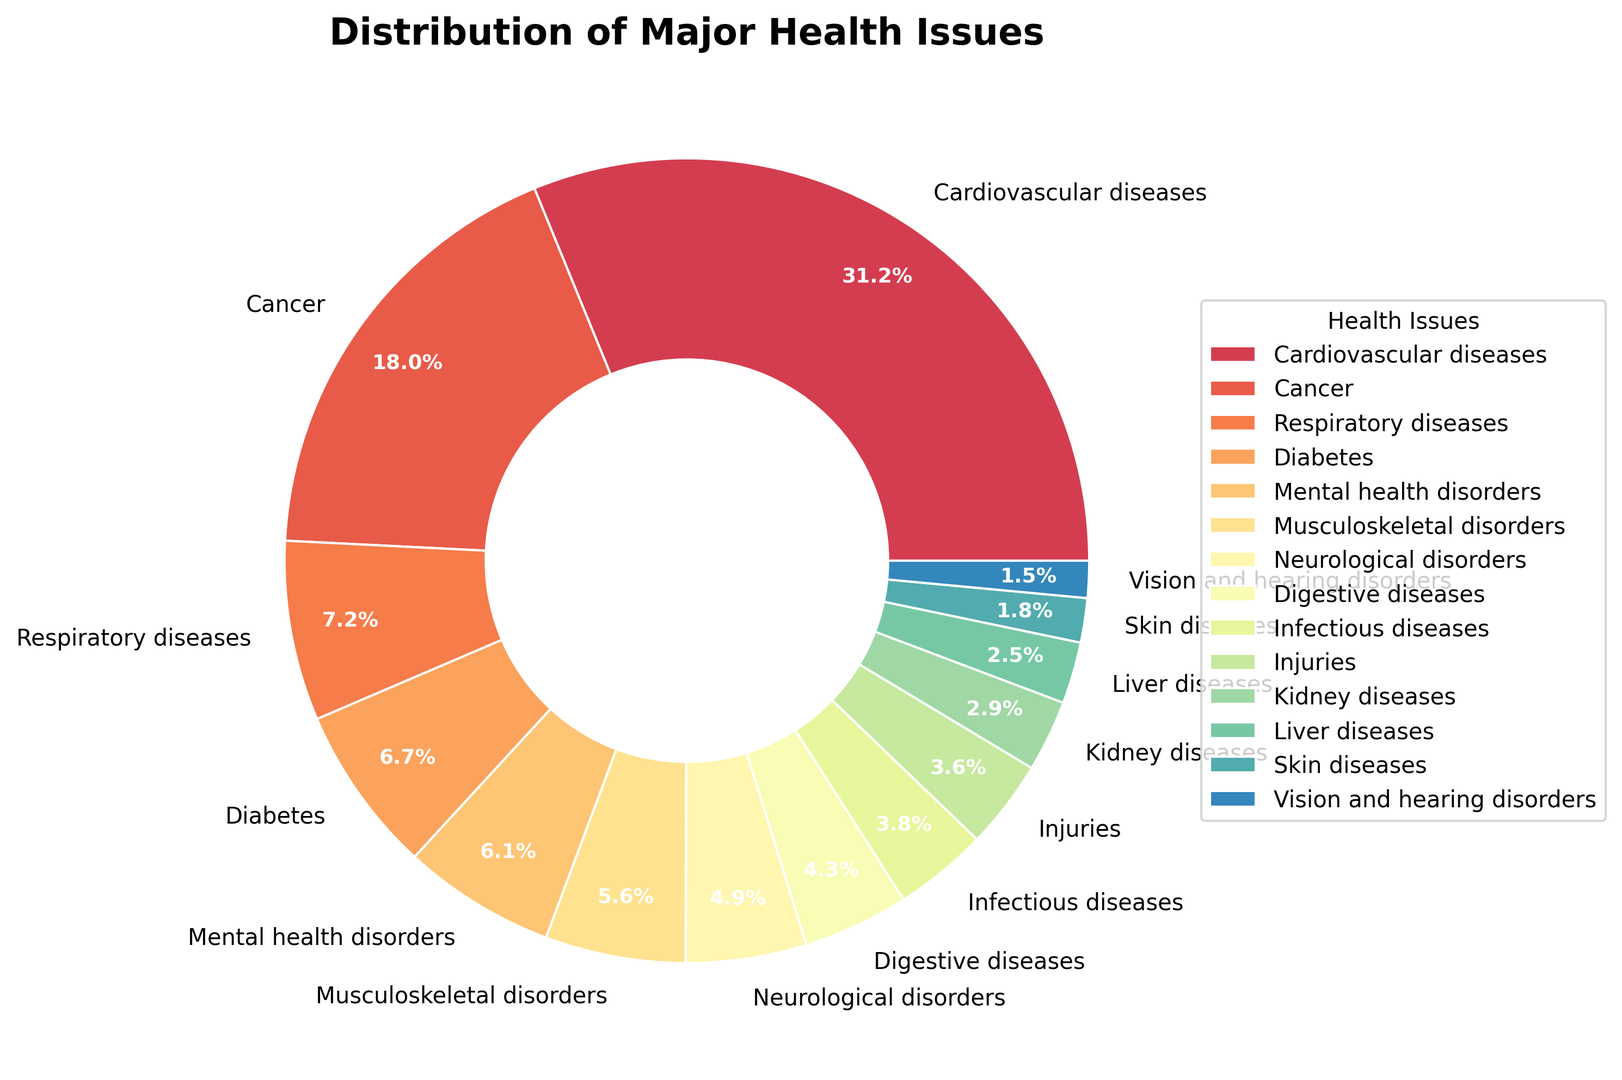Which health issue has the highest percentage? The largest section of the pie chart, representing Cardiovascular diseases, shows the highest percentage.
Answer: Cardiovascular diseases What is the combined percentage of Respiratory diseases and Diabetes? Add the percentage values for Respiratory diseases (7.3%) and Diabetes (6.8%) from the chart: 7.3 + 6.8 = 14.1%
Answer: 14.1% Which health issue has a greater percentage, Musculoskeletal disorders or Mental health disorders? Compare the percentages from the chart: Musculoskeletal disorders (5.7%) and Mental health disorders (6.2%). Mental health disorders have a greater percentage.
Answer: Mental health disorders How does the percentage of Liver diseases compare to that of Kidney diseases? Find the percentages from the chart: Liver diseases (2.5%) and Kidney diseases (2.9%). Kidney diseases have a higher percentage than Liver diseases.
Answer: Kidney diseases What is the percentage difference between Cancer and Infectious diseases? Calculate the difference between the percentages of Cancer (18.2%) and Infectious diseases (3.8%): 18.2 - 3.8 = 14.4%
Answer: 14.4% Which three health issues have the smallest percentages and what is their combined percentage? Identify the health issues with the smallest percentages: Vision and hearing disorders (1.5%), Skin diseases (1.8%), and Liver diseases (2.5%). Add them together: 1.5 + 1.8 + 2.5 = 5.8%
Answer: 5.8% What is the average percentage of the top four health issues? Identify the top four health issues: Cardiovascular diseases (31.5%), Cancer (18.2%), Respiratory diseases (7.3%), and Diabetes (6.8%). Calculate the average: (31.5 + 18.2 + 7.3 + 6.8) / 4 = 15.95%
Answer: 15.95% Which is the least prevalent health issue and what color represents it on the chart? The least prevalent health issue is Vision and hearing disorders (1.5%). It is represented by the section color corresponding to its placement in the legend.
Answer: Vision and hearing disorders, observe the color in the legend What is the total percentage of health issues that account for less than 5% each? Identify the health issues with percentages less than 5%: Neurological disorders (4.9%), Digestive diseases (4.3%), Infectious diseases (3.8%), Injuries (3.6%), Kidney diseases (2.9%), Liver diseases (2.5%), Skin diseases (1.8%), Vision and hearing disorders (1.5%). Add them together: 4.9 + 4.3 + 3.8 + 3.6 + 2.9 + 2.5 + 1.8 + 1.5 = 25.3%
Answer: 25.3% 